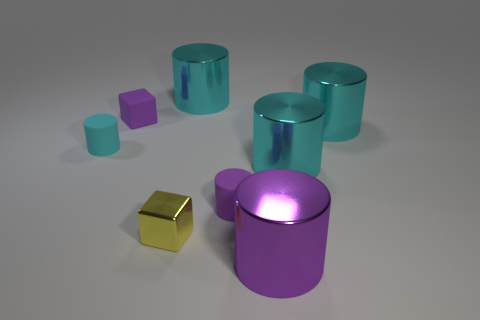Is the number of yellow blocks that are left of the small cyan cylinder greater than the number of small red shiny cylinders?
Make the answer very short. No. Is there anything else that is the same shape as the large purple object?
Make the answer very short. Yes. There is another thing that is the same shape as the yellow metallic object; what is its color?
Provide a short and direct response. Purple. The purple rubber object that is left of the small shiny cube has what shape?
Your response must be concise. Cube. Are there any cyan metal objects in front of the purple matte cube?
Keep it short and to the point. Yes. Is there anything else that has the same size as the yellow thing?
Your answer should be very brief. Yes. There is another tiny cylinder that is the same material as the tiny cyan cylinder; what color is it?
Your answer should be very brief. Purple. There is a tiny rubber object on the left side of the matte cube; is its color the same as the small block that is in front of the cyan matte thing?
Provide a short and direct response. No. What number of cylinders are either cyan metal objects or tiny yellow objects?
Offer a very short reply. 3. Are there the same number of small purple matte cubes that are behind the purple block and tiny matte objects?
Make the answer very short. No. 